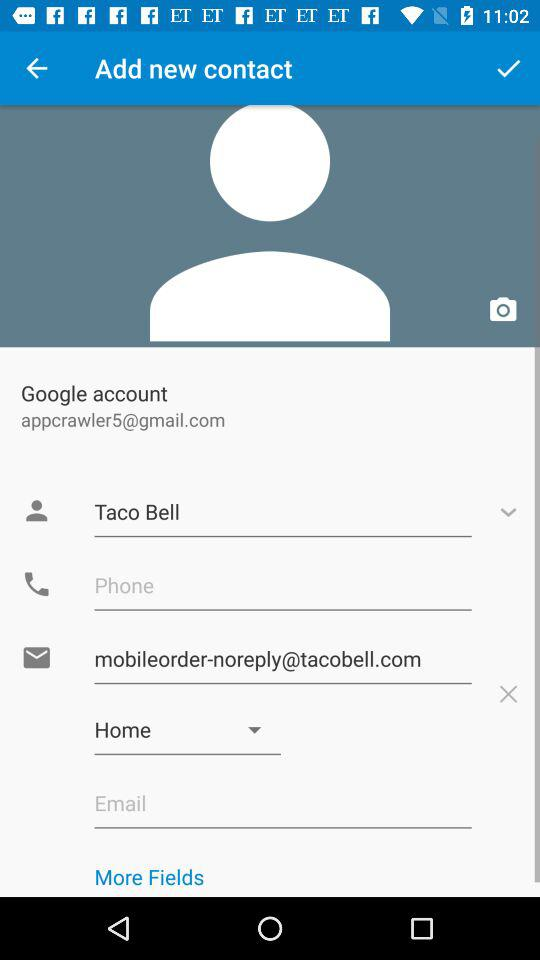How many fields are there for contact information?
Answer the question using a single word or phrase. 5 